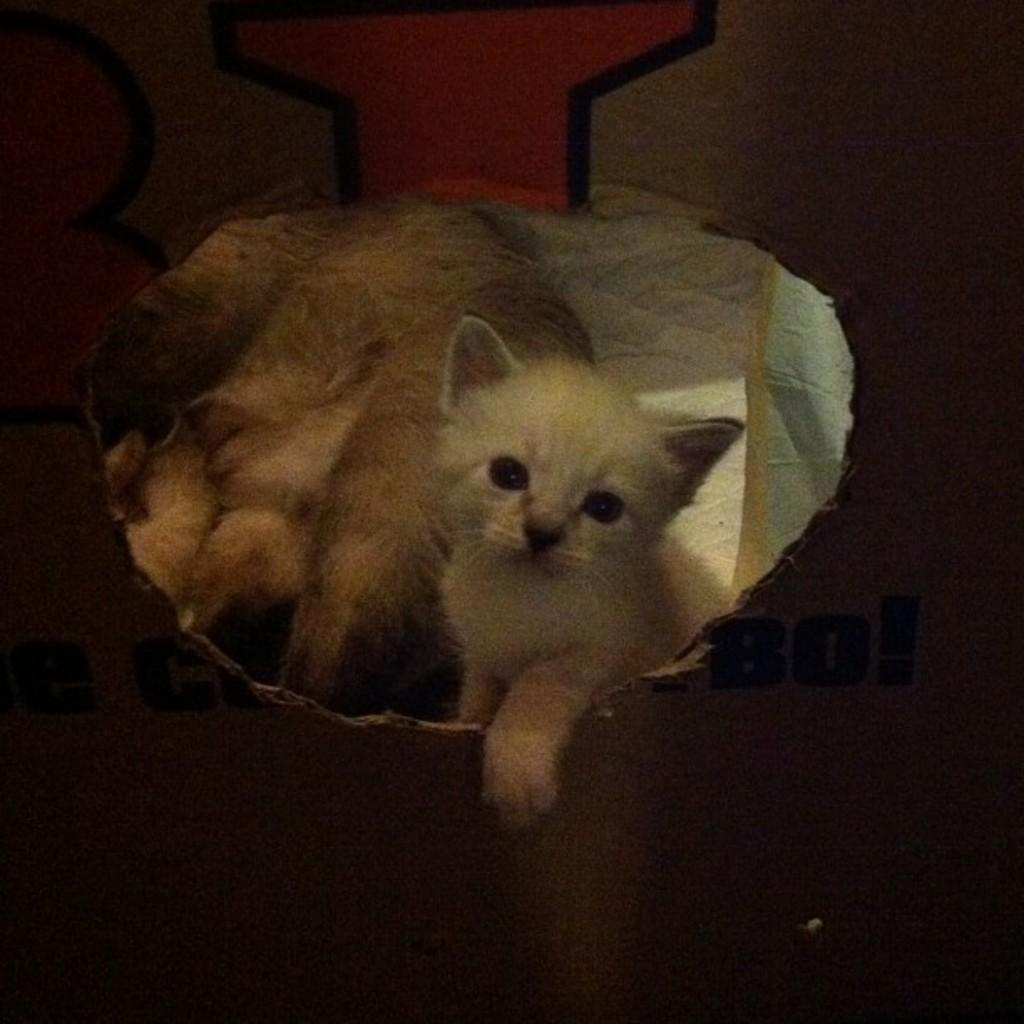What is the overall lighting condition of the image? The picture is dark. What types of living organisms can be seen in the image? There are animals in the picture. What emotion do the animals in the picture express? The image does not convey any emotions or expressions of the animals, as it is a still picture. 